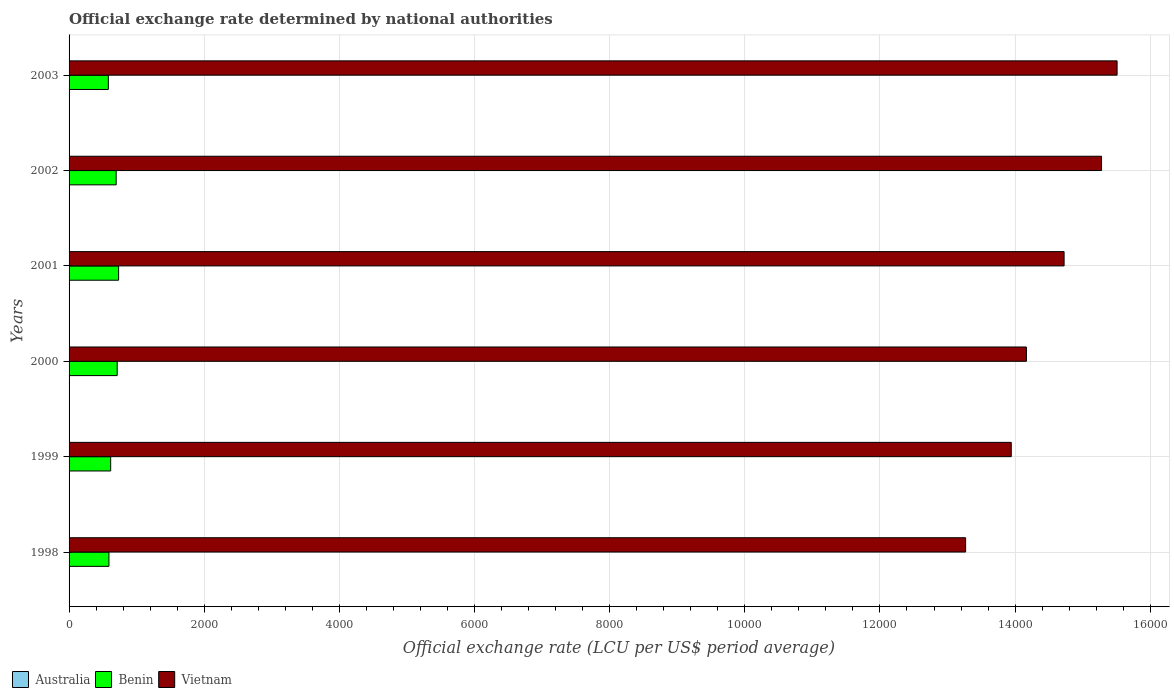Are the number of bars per tick equal to the number of legend labels?
Ensure brevity in your answer.  Yes. Are the number of bars on each tick of the Y-axis equal?
Ensure brevity in your answer.  Yes. How many bars are there on the 4th tick from the bottom?
Your answer should be compact. 3. What is the label of the 3rd group of bars from the top?
Your answer should be very brief. 2001. What is the official exchange rate in Australia in 2000?
Keep it short and to the point. 1.72. Across all years, what is the maximum official exchange rate in Vietnam?
Make the answer very short. 1.55e+04. Across all years, what is the minimum official exchange rate in Australia?
Provide a short and direct response. 1.54. What is the total official exchange rate in Vietnam in the graph?
Offer a very short reply. 8.69e+04. What is the difference between the official exchange rate in Benin in 1998 and that in 2001?
Your response must be concise. -143.09. What is the difference between the official exchange rate in Vietnam in 1999 and the official exchange rate in Benin in 2002?
Your response must be concise. 1.32e+04. What is the average official exchange rate in Benin per year?
Your answer should be very brief. 654.81. In the year 2003, what is the difference between the official exchange rate in Australia and official exchange rate in Vietnam?
Give a very brief answer. -1.55e+04. What is the ratio of the official exchange rate in Vietnam in 2000 to that in 2002?
Your answer should be very brief. 0.93. Is the official exchange rate in Australia in 1999 less than that in 2000?
Your answer should be compact. Yes. Is the difference between the official exchange rate in Australia in 1998 and 2002 greater than the difference between the official exchange rate in Vietnam in 1998 and 2002?
Your answer should be compact. Yes. What is the difference between the highest and the second highest official exchange rate in Australia?
Offer a very short reply. 0.09. What is the difference between the highest and the lowest official exchange rate in Australia?
Make the answer very short. 0.39. In how many years, is the official exchange rate in Australia greater than the average official exchange rate in Australia taken over all years?
Your answer should be compact. 3. What does the 2nd bar from the top in 1998 represents?
Provide a succinct answer. Benin. Are all the bars in the graph horizontal?
Your answer should be compact. Yes. How many years are there in the graph?
Provide a succinct answer. 6. Does the graph contain grids?
Keep it short and to the point. Yes. Where does the legend appear in the graph?
Offer a very short reply. Bottom left. How many legend labels are there?
Ensure brevity in your answer.  3. How are the legend labels stacked?
Keep it short and to the point. Horizontal. What is the title of the graph?
Provide a short and direct response. Official exchange rate determined by national authorities. Does "Mauritania" appear as one of the legend labels in the graph?
Ensure brevity in your answer.  No. What is the label or title of the X-axis?
Offer a very short reply. Official exchange rate (LCU per US$ period average). What is the Official exchange rate (LCU per US$ period average) of Australia in 1998?
Offer a terse response. 1.59. What is the Official exchange rate (LCU per US$ period average) of Benin in 1998?
Ensure brevity in your answer.  589.95. What is the Official exchange rate (LCU per US$ period average) of Vietnam in 1998?
Offer a very short reply. 1.33e+04. What is the Official exchange rate (LCU per US$ period average) in Australia in 1999?
Your response must be concise. 1.55. What is the Official exchange rate (LCU per US$ period average) in Benin in 1999?
Your answer should be compact. 615.7. What is the Official exchange rate (LCU per US$ period average) in Vietnam in 1999?
Your answer should be very brief. 1.39e+04. What is the Official exchange rate (LCU per US$ period average) of Australia in 2000?
Give a very brief answer. 1.72. What is the Official exchange rate (LCU per US$ period average) in Benin in 2000?
Offer a very short reply. 711.98. What is the Official exchange rate (LCU per US$ period average) of Vietnam in 2000?
Your answer should be very brief. 1.42e+04. What is the Official exchange rate (LCU per US$ period average) of Australia in 2001?
Give a very brief answer. 1.93. What is the Official exchange rate (LCU per US$ period average) in Benin in 2001?
Offer a very short reply. 733.04. What is the Official exchange rate (LCU per US$ period average) of Vietnam in 2001?
Make the answer very short. 1.47e+04. What is the Official exchange rate (LCU per US$ period average) in Australia in 2002?
Your answer should be compact. 1.84. What is the Official exchange rate (LCU per US$ period average) of Benin in 2002?
Keep it short and to the point. 696.99. What is the Official exchange rate (LCU per US$ period average) in Vietnam in 2002?
Offer a very short reply. 1.53e+04. What is the Official exchange rate (LCU per US$ period average) of Australia in 2003?
Provide a succinct answer. 1.54. What is the Official exchange rate (LCU per US$ period average) in Benin in 2003?
Make the answer very short. 581.2. What is the Official exchange rate (LCU per US$ period average) of Vietnam in 2003?
Your response must be concise. 1.55e+04. Across all years, what is the maximum Official exchange rate (LCU per US$ period average) in Australia?
Ensure brevity in your answer.  1.93. Across all years, what is the maximum Official exchange rate (LCU per US$ period average) of Benin?
Your answer should be compact. 733.04. Across all years, what is the maximum Official exchange rate (LCU per US$ period average) of Vietnam?
Keep it short and to the point. 1.55e+04. Across all years, what is the minimum Official exchange rate (LCU per US$ period average) of Australia?
Provide a succinct answer. 1.54. Across all years, what is the minimum Official exchange rate (LCU per US$ period average) of Benin?
Your answer should be very brief. 581.2. Across all years, what is the minimum Official exchange rate (LCU per US$ period average) in Vietnam?
Ensure brevity in your answer.  1.33e+04. What is the total Official exchange rate (LCU per US$ period average) of Australia in the graph?
Keep it short and to the point. 10.18. What is the total Official exchange rate (LCU per US$ period average) in Benin in the graph?
Provide a succinct answer. 3928.85. What is the total Official exchange rate (LCU per US$ period average) in Vietnam in the graph?
Provide a succinct answer. 8.69e+04. What is the difference between the Official exchange rate (LCU per US$ period average) in Australia in 1998 and that in 1999?
Keep it short and to the point. 0.04. What is the difference between the Official exchange rate (LCU per US$ period average) in Benin in 1998 and that in 1999?
Your answer should be compact. -25.75. What is the difference between the Official exchange rate (LCU per US$ period average) of Vietnam in 1998 and that in 1999?
Offer a terse response. -675.17. What is the difference between the Official exchange rate (LCU per US$ period average) in Australia in 1998 and that in 2000?
Provide a short and direct response. -0.13. What is the difference between the Official exchange rate (LCU per US$ period average) of Benin in 1998 and that in 2000?
Your answer should be very brief. -122.02. What is the difference between the Official exchange rate (LCU per US$ period average) of Vietnam in 1998 and that in 2000?
Provide a succinct answer. -899.75. What is the difference between the Official exchange rate (LCU per US$ period average) of Australia in 1998 and that in 2001?
Offer a very short reply. -0.34. What is the difference between the Official exchange rate (LCU per US$ period average) in Benin in 1998 and that in 2001?
Your answer should be very brief. -143.09. What is the difference between the Official exchange rate (LCU per US$ period average) in Vietnam in 1998 and that in 2001?
Provide a short and direct response. -1457.17. What is the difference between the Official exchange rate (LCU per US$ period average) in Australia in 1998 and that in 2002?
Your answer should be compact. -0.25. What is the difference between the Official exchange rate (LCU per US$ period average) of Benin in 1998 and that in 2002?
Make the answer very short. -107.04. What is the difference between the Official exchange rate (LCU per US$ period average) in Vietnam in 1998 and that in 2002?
Make the answer very short. -2011.5. What is the difference between the Official exchange rate (LCU per US$ period average) of Australia in 1998 and that in 2003?
Offer a terse response. 0.05. What is the difference between the Official exchange rate (LCU per US$ period average) of Benin in 1998 and that in 2003?
Ensure brevity in your answer.  8.75. What is the difference between the Official exchange rate (LCU per US$ period average) in Vietnam in 1998 and that in 2003?
Your response must be concise. -2241.58. What is the difference between the Official exchange rate (LCU per US$ period average) in Australia in 1999 and that in 2000?
Offer a very short reply. -0.17. What is the difference between the Official exchange rate (LCU per US$ period average) in Benin in 1999 and that in 2000?
Offer a terse response. -96.28. What is the difference between the Official exchange rate (LCU per US$ period average) in Vietnam in 1999 and that in 2000?
Offer a terse response. -224.58. What is the difference between the Official exchange rate (LCU per US$ period average) in Australia in 1999 and that in 2001?
Your response must be concise. -0.38. What is the difference between the Official exchange rate (LCU per US$ period average) in Benin in 1999 and that in 2001?
Your response must be concise. -117.34. What is the difference between the Official exchange rate (LCU per US$ period average) in Vietnam in 1999 and that in 2001?
Keep it short and to the point. -782. What is the difference between the Official exchange rate (LCU per US$ period average) of Australia in 1999 and that in 2002?
Your answer should be very brief. -0.29. What is the difference between the Official exchange rate (LCU per US$ period average) of Benin in 1999 and that in 2002?
Provide a short and direct response. -81.29. What is the difference between the Official exchange rate (LCU per US$ period average) in Vietnam in 1999 and that in 2002?
Your answer should be compact. -1336.33. What is the difference between the Official exchange rate (LCU per US$ period average) in Australia in 1999 and that in 2003?
Keep it short and to the point. 0.01. What is the difference between the Official exchange rate (LCU per US$ period average) of Benin in 1999 and that in 2003?
Provide a succinct answer. 34.5. What is the difference between the Official exchange rate (LCU per US$ period average) in Vietnam in 1999 and that in 2003?
Your response must be concise. -1566.42. What is the difference between the Official exchange rate (LCU per US$ period average) in Australia in 2000 and that in 2001?
Give a very brief answer. -0.21. What is the difference between the Official exchange rate (LCU per US$ period average) in Benin in 2000 and that in 2001?
Keep it short and to the point. -21.06. What is the difference between the Official exchange rate (LCU per US$ period average) of Vietnam in 2000 and that in 2001?
Give a very brief answer. -557.42. What is the difference between the Official exchange rate (LCU per US$ period average) in Australia in 2000 and that in 2002?
Make the answer very short. -0.12. What is the difference between the Official exchange rate (LCU per US$ period average) of Benin in 2000 and that in 2002?
Provide a succinct answer. 14.99. What is the difference between the Official exchange rate (LCU per US$ period average) in Vietnam in 2000 and that in 2002?
Provide a short and direct response. -1111.75. What is the difference between the Official exchange rate (LCU per US$ period average) in Australia in 2000 and that in 2003?
Keep it short and to the point. 0.18. What is the difference between the Official exchange rate (LCU per US$ period average) in Benin in 2000 and that in 2003?
Give a very brief answer. 130.78. What is the difference between the Official exchange rate (LCU per US$ period average) in Vietnam in 2000 and that in 2003?
Ensure brevity in your answer.  -1341.83. What is the difference between the Official exchange rate (LCU per US$ period average) of Australia in 2001 and that in 2002?
Ensure brevity in your answer.  0.09. What is the difference between the Official exchange rate (LCU per US$ period average) of Benin in 2001 and that in 2002?
Your answer should be very brief. 36.05. What is the difference between the Official exchange rate (LCU per US$ period average) of Vietnam in 2001 and that in 2002?
Offer a terse response. -554.33. What is the difference between the Official exchange rate (LCU per US$ period average) in Australia in 2001 and that in 2003?
Your response must be concise. 0.39. What is the difference between the Official exchange rate (LCU per US$ period average) of Benin in 2001 and that in 2003?
Give a very brief answer. 151.84. What is the difference between the Official exchange rate (LCU per US$ period average) of Vietnam in 2001 and that in 2003?
Your answer should be very brief. -784.42. What is the difference between the Official exchange rate (LCU per US$ period average) of Australia in 2002 and that in 2003?
Ensure brevity in your answer.  0.3. What is the difference between the Official exchange rate (LCU per US$ period average) of Benin in 2002 and that in 2003?
Make the answer very short. 115.79. What is the difference between the Official exchange rate (LCU per US$ period average) in Vietnam in 2002 and that in 2003?
Offer a very short reply. -230.08. What is the difference between the Official exchange rate (LCU per US$ period average) of Australia in 1998 and the Official exchange rate (LCU per US$ period average) of Benin in 1999?
Provide a succinct answer. -614.11. What is the difference between the Official exchange rate (LCU per US$ period average) of Australia in 1998 and the Official exchange rate (LCU per US$ period average) of Vietnam in 1999?
Your response must be concise. -1.39e+04. What is the difference between the Official exchange rate (LCU per US$ period average) in Benin in 1998 and the Official exchange rate (LCU per US$ period average) in Vietnam in 1999?
Make the answer very short. -1.34e+04. What is the difference between the Official exchange rate (LCU per US$ period average) of Australia in 1998 and the Official exchange rate (LCU per US$ period average) of Benin in 2000?
Provide a succinct answer. -710.38. What is the difference between the Official exchange rate (LCU per US$ period average) of Australia in 1998 and the Official exchange rate (LCU per US$ period average) of Vietnam in 2000?
Your answer should be compact. -1.42e+04. What is the difference between the Official exchange rate (LCU per US$ period average) of Benin in 1998 and the Official exchange rate (LCU per US$ period average) of Vietnam in 2000?
Ensure brevity in your answer.  -1.36e+04. What is the difference between the Official exchange rate (LCU per US$ period average) in Australia in 1998 and the Official exchange rate (LCU per US$ period average) in Benin in 2001?
Offer a very short reply. -731.45. What is the difference between the Official exchange rate (LCU per US$ period average) of Australia in 1998 and the Official exchange rate (LCU per US$ period average) of Vietnam in 2001?
Give a very brief answer. -1.47e+04. What is the difference between the Official exchange rate (LCU per US$ period average) in Benin in 1998 and the Official exchange rate (LCU per US$ period average) in Vietnam in 2001?
Offer a terse response. -1.41e+04. What is the difference between the Official exchange rate (LCU per US$ period average) in Australia in 1998 and the Official exchange rate (LCU per US$ period average) in Benin in 2002?
Ensure brevity in your answer.  -695.4. What is the difference between the Official exchange rate (LCU per US$ period average) of Australia in 1998 and the Official exchange rate (LCU per US$ period average) of Vietnam in 2002?
Your response must be concise. -1.53e+04. What is the difference between the Official exchange rate (LCU per US$ period average) in Benin in 1998 and the Official exchange rate (LCU per US$ period average) in Vietnam in 2002?
Give a very brief answer. -1.47e+04. What is the difference between the Official exchange rate (LCU per US$ period average) in Australia in 1998 and the Official exchange rate (LCU per US$ period average) in Benin in 2003?
Make the answer very short. -579.61. What is the difference between the Official exchange rate (LCU per US$ period average) of Australia in 1998 and the Official exchange rate (LCU per US$ period average) of Vietnam in 2003?
Ensure brevity in your answer.  -1.55e+04. What is the difference between the Official exchange rate (LCU per US$ period average) of Benin in 1998 and the Official exchange rate (LCU per US$ period average) of Vietnam in 2003?
Give a very brief answer. -1.49e+04. What is the difference between the Official exchange rate (LCU per US$ period average) of Australia in 1999 and the Official exchange rate (LCU per US$ period average) of Benin in 2000?
Keep it short and to the point. -710.43. What is the difference between the Official exchange rate (LCU per US$ period average) in Australia in 1999 and the Official exchange rate (LCU per US$ period average) in Vietnam in 2000?
Your response must be concise. -1.42e+04. What is the difference between the Official exchange rate (LCU per US$ period average) of Benin in 1999 and the Official exchange rate (LCU per US$ period average) of Vietnam in 2000?
Make the answer very short. -1.36e+04. What is the difference between the Official exchange rate (LCU per US$ period average) in Australia in 1999 and the Official exchange rate (LCU per US$ period average) in Benin in 2001?
Your response must be concise. -731.49. What is the difference between the Official exchange rate (LCU per US$ period average) of Australia in 1999 and the Official exchange rate (LCU per US$ period average) of Vietnam in 2001?
Ensure brevity in your answer.  -1.47e+04. What is the difference between the Official exchange rate (LCU per US$ period average) in Benin in 1999 and the Official exchange rate (LCU per US$ period average) in Vietnam in 2001?
Make the answer very short. -1.41e+04. What is the difference between the Official exchange rate (LCU per US$ period average) in Australia in 1999 and the Official exchange rate (LCU per US$ period average) in Benin in 2002?
Give a very brief answer. -695.44. What is the difference between the Official exchange rate (LCU per US$ period average) in Australia in 1999 and the Official exchange rate (LCU per US$ period average) in Vietnam in 2002?
Give a very brief answer. -1.53e+04. What is the difference between the Official exchange rate (LCU per US$ period average) in Benin in 1999 and the Official exchange rate (LCU per US$ period average) in Vietnam in 2002?
Offer a terse response. -1.47e+04. What is the difference between the Official exchange rate (LCU per US$ period average) in Australia in 1999 and the Official exchange rate (LCU per US$ period average) in Benin in 2003?
Give a very brief answer. -579.65. What is the difference between the Official exchange rate (LCU per US$ period average) in Australia in 1999 and the Official exchange rate (LCU per US$ period average) in Vietnam in 2003?
Your response must be concise. -1.55e+04. What is the difference between the Official exchange rate (LCU per US$ period average) of Benin in 1999 and the Official exchange rate (LCU per US$ period average) of Vietnam in 2003?
Ensure brevity in your answer.  -1.49e+04. What is the difference between the Official exchange rate (LCU per US$ period average) of Australia in 2000 and the Official exchange rate (LCU per US$ period average) of Benin in 2001?
Your answer should be compact. -731.31. What is the difference between the Official exchange rate (LCU per US$ period average) of Australia in 2000 and the Official exchange rate (LCU per US$ period average) of Vietnam in 2001?
Your response must be concise. -1.47e+04. What is the difference between the Official exchange rate (LCU per US$ period average) in Benin in 2000 and the Official exchange rate (LCU per US$ period average) in Vietnam in 2001?
Keep it short and to the point. -1.40e+04. What is the difference between the Official exchange rate (LCU per US$ period average) of Australia in 2000 and the Official exchange rate (LCU per US$ period average) of Benin in 2002?
Give a very brief answer. -695.26. What is the difference between the Official exchange rate (LCU per US$ period average) in Australia in 2000 and the Official exchange rate (LCU per US$ period average) in Vietnam in 2002?
Offer a very short reply. -1.53e+04. What is the difference between the Official exchange rate (LCU per US$ period average) of Benin in 2000 and the Official exchange rate (LCU per US$ period average) of Vietnam in 2002?
Ensure brevity in your answer.  -1.46e+04. What is the difference between the Official exchange rate (LCU per US$ period average) of Australia in 2000 and the Official exchange rate (LCU per US$ period average) of Benin in 2003?
Ensure brevity in your answer.  -579.48. What is the difference between the Official exchange rate (LCU per US$ period average) of Australia in 2000 and the Official exchange rate (LCU per US$ period average) of Vietnam in 2003?
Provide a succinct answer. -1.55e+04. What is the difference between the Official exchange rate (LCU per US$ period average) in Benin in 2000 and the Official exchange rate (LCU per US$ period average) in Vietnam in 2003?
Keep it short and to the point. -1.48e+04. What is the difference between the Official exchange rate (LCU per US$ period average) in Australia in 2001 and the Official exchange rate (LCU per US$ period average) in Benin in 2002?
Provide a short and direct response. -695.05. What is the difference between the Official exchange rate (LCU per US$ period average) of Australia in 2001 and the Official exchange rate (LCU per US$ period average) of Vietnam in 2002?
Provide a short and direct response. -1.53e+04. What is the difference between the Official exchange rate (LCU per US$ period average) in Benin in 2001 and the Official exchange rate (LCU per US$ period average) in Vietnam in 2002?
Make the answer very short. -1.45e+04. What is the difference between the Official exchange rate (LCU per US$ period average) in Australia in 2001 and the Official exchange rate (LCU per US$ period average) in Benin in 2003?
Give a very brief answer. -579.27. What is the difference between the Official exchange rate (LCU per US$ period average) of Australia in 2001 and the Official exchange rate (LCU per US$ period average) of Vietnam in 2003?
Ensure brevity in your answer.  -1.55e+04. What is the difference between the Official exchange rate (LCU per US$ period average) of Benin in 2001 and the Official exchange rate (LCU per US$ period average) of Vietnam in 2003?
Keep it short and to the point. -1.48e+04. What is the difference between the Official exchange rate (LCU per US$ period average) of Australia in 2002 and the Official exchange rate (LCU per US$ period average) of Benin in 2003?
Offer a very short reply. -579.36. What is the difference between the Official exchange rate (LCU per US$ period average) of Australia in 2002 and the Official exchange rate (LCU per US$ period average) of Vietnam in 2003?
Your answer should be compact. -1.55e+04. What is the difference between the Official exchange rate (LCU per US$ period average) of Benin in 2002 and the Official exchange rate (LCU per US$ period average) of Vietnam in 2003?
Your answer should be very brief. -1.48e+04. What is the average Official exchange rate (LCU per US$ period average) in Australia per year?
Provide a short and direct response. 1.7. What is the average Official exchange rate (LCU per US$ period average) of Benin per year?
Provide a short and direct response. 654.81. What is the average Official exchange rate (LCU per US$ period average) of Vietnam per year?
Ensure brevity in your answer.  1.45e+04. In the year 1998, what is the difference between the Official exchange rate (LCU per US$ period average) of Australia and Official exchange rate (LCU per US$ period average) of Benin?
Provide a succinct answer. -588.36. In the year 1998, what is the difference between the Official exchange rate (LCU per US$ period average) of Australia and Official exchange rate (LCU per US$ period average) of Vietnam?
Keep it short and to the point. -1.33e+04. In the year 1998, what is the difference between the Official exchange rate (LCU per US$ period average) of Benin and Official exchange rate (LCU per US$ period average) of Vietnam?
Give a very brief answer. -1.27e+04. In the year 1999, what is the difference between the Official exchange rate (LCU per US$ period average) of Australia and Official exchange rate (LCU per US$ period average) of Benin?
Provide a succinct answer. -614.15. In the year 1999, what is the difference between the Official exchange rate (LCU per US$ period average) of Australia and Official exchange rate (LCU per US$ period average) of Vietnam?
Make the answer very short. -1.39e+04. In the year 1999, what is the difference between the Official exchange rate (LCU per US$ period average) in Benin and Official exchange rate (LCU per US$ period average) in Vietnam?
Make the answer very short. -1.33e+04. In the year 2000, what is the difference between the Official exchange rate (LCU per US$ period average) of Australia and Official exchange rate (LCU per US$ period average) of Benin?
Your answer should be compact. -710.25. In the year 2000, what is the difference between the Official exchange rate (LCU per US$ period average) in Australia and Official exchange rate (LCU per US$ period average) in Vietnam?
Your response must be concise. -1.42e+04. In the year 2000, what is the difference between the Official exchange rate (LCU per US$ period average) in Benin and Official exchange rate (LCU per US$ period average) in Vietnam?
Provide a short and direct response. -1.35e+04. In the year 2001, what is the difference between the Official exchange rate (LCU per US$ period average) in Australia and Official exchange rate (LCU per US$ period average) in Benin?
Your answer should be very brief. -731.11. In the year 2001, what is the difference between the Official exchange rate (LCU per US$ period average) of Australia and Official exchange rate (LCU per US$ period average) of Vietnam?
Offer a terse response. -1.47e+04. In the year 2001, what is the difference between the Official exchange rate (LCU per US$ period average) of Benin and Official exchange rate (LCU per US$ period average) of Vietnam?
Your answer should be very brief. -1.40e+04. In the year 2002, what is the difference between the Official exchange rate (LCU per US$ period average) of Australia and Official exchange rate (LCU per US$ period average) of Benin?
Ensure brevity in your answer.  -695.15. In the year 2002, what is the difference between the Official exchange rate (LCU per US$ period average) of Australia and Official exchange rate (LCU per US$ period average) of Vietnam?
Give a very brief answer. -1.53e+04. In the year 2002, what is the difference between the Official exchange rate (LCU per US$ period average) of Benin and Official exchange rate (LCU per US$ period average) of Vietnam?
Make the answer very short. -1.46e+04. In the year 2003, what is the difference between the Official exchange rate (LCU per US$ period average) of Australia and Official exchange rate (LCU per US$ period average) of Benin?
Ensure brevity in your answer.  -579.66. In the year 2003, what is the difference between the Official exchange rate (LCU per US$ period average) in Australia and Official exchange rate (LCU per US$ period average) in Vietnam?
Your answer should be compact. -1.55e+04. In the year 2003, what is the difference between the Official exchange rate (LCU per US$ period average) in Benin and Official exchange rate (LCU per US$ period average) in Vietnam?
Your response must be concise. -1.49e+04. What is the ratio of the Official exchange rate (LCU per US$ period average) of Benin in 1998 to that in 1999?
Provide a short and direct response. 0.96. What is the ratio of the Official exchange rate (LCU per US$ period average) of Vietnam in 1998 to that in 1999?
Ensure brevity in your answer.  0.95. What is the ratio of the Official exchange rate (LCU per US$ period average) in Australia in 1998 to that in 2000?
Your response must be concise. 0.92. What is the ratio of the Official exchange rate (LCU per US$ period average) of Benin in 1998 to that in 2000?
Your answer should be compact. 0.83. What is the ratio of the Official exchange rate (LCU per US$ period average) in Vietnam in 1998 to that in 2000?
Ensure brevity in your answer.  0.94. What is the ratio of the Official exchange rate (LCU per US$ period average) in Australia in 1998 to that in 2001?
Offer a terse response. 0.82. What is the ratio of the Official exchange rate (LCU per US$ period average) of Benin in 1998 to that in 2001?
Your answer should be compact. 0.8. What is the ratio of the Official exchange rate (LCU per US$ period average) of Vietnam in 1998 to that in 2001?
Offer a terse response. 0.9. What is the ratio of the Official exchange rate (LCU per US$ period average) in Australia in 1998 to that in 2002?
Your answer should be very brief. 0.86. What is the ratio of the Official exchange rate (LCU per US$ period average) in Benin in 1998 to that in 2002?
Make the answer very short. 0.85. What is the ratio of the Official exchange rate (LCU per US$ period average) in Vietnam in 1998 to that in 2002?
Ensure brevity in your answer.  0.87. What is the ratio of the Official exchange rate (LCU per US$ period average) in Australia in 1998 to that in 2003?
Provide a succinct answer. 1.03. What is the ratio of the Official exchange rate (LCU per US$ period average) of Benin in 1998 to that in 2003?
Provide a succinct answer. 1.02. What is the ratio of the Official exchange rate (LCU per US$ period average) in Vietnam in 1998 to that in 2003?
Keep it short and to the point. 0.86. What is the ratio of the Official exchange rate (LCU per US$ period average) of Australia in 1999 to that in 2000?
Your answer should be very brief. 0.9. What is the ratio of the Official exchange rate (LCU per US$ period average) in Benin in 1999 to that in 2000?
Offer a terse response. 0.86. What is the ratio of the Official exchange rate (LCU per US$ period average) of Vietnam in 1999 to that in 2000?
Provide a succinct answer. 0.98. What is the ratio of the Official exchange rate (LCU per US$ period average) of Australia in 1999 to that in 2001?
Offer a terse response. 0.8. What is the ratio of the Official exchange rate (LCU per US$ period average) of Benin in 1999 to that in 2001?
Your answer should be very brief. 0.84. What is the ratio of the Official exchange rate (LCU per US$ period average) in Vietnam in 1999 to that in 2001?
Keep it short and to the point. 0.95. What is the ratio of the Official exchange rate (LCU per US$ period average) of Australia in 1999 to that in 2002?
Provide a short and direct response. 0.84. What is the ratio of the Official exchange rate (LCU per US$ period average) of Benin in 1999 to that in 2002?
Offer a very short reply. 0.88. What is the ratio of the Official exchange rate (LCU per US$ period average) of Vietnam in 1999 to that in 2002?
Make the answer very short. 0.91. What is the ratio of the Official exchange rate (LCU per US$ period average) in Benin in 1999 to that in 2003?
Your answer should be very brief. 1.06. What is the ratio of the Official exchange rate (LCU per US$ period average) in Vietnam in 1999 to that in 2003?
Your answer should be compact. 0.9. What is the ratio of the Official exchange rate (LCU per US$ period average) in Australia in 2000 to that in 2001?
Provide a short and direct response. 0.89. What is the ratio of the Official exchange rate (LCU per US$ period average) in Benin in 2000 to that in 2001?
Your answer should be compact. 0.97. What is the ratio of the Official exchange rate (LCU per US$ period average) in Vietnam in 2000 to that in 2001?
Offer a terse response. 0.96. What is the ratio of the Official exchange rate (LCU per US$ period average) of Australia in 2000 to that in 2002?
Offer a terse response. 0.94. What is the ratio of the Official exchange rate (LCU per US$ period average) in Benin in 2000 to that in 2002?
Provide a succinct answer. 1.02. What is the ratio of the Official exchange rate (LCU per US$ period average) in Vietnam in 2000 to that in 2002?
Your response must be concise. 0.93. What is the ratio of the Official exchange rate (LCU per US$ period average) in Australia in 2000 to that in 2003?
Provide a succinct answer. 1.12. What is the ratio of the Official exchange rate (LCU per US$ period average) in Benin in 2000 to that in 2003?
Ensure brevity in your answer.  1.23. What is the ratio of the Official exchange rate (LCU per US$ period average) in Vietnam in 2000 to that in 2003?
Offer a terse response. 0.91. What is the ratio of the Official exchange rate (LCU per US$ period average) of Australia in 2001 to that in 2002?
Your answer should be compact. 1.05. What is the ratio of the Official exchange rate (LCU per US$ period average) of Benin in 2001 to that in 2002?
Provide a short and direct response. 1.05. What is the ratio of the Official exchange rate (LCU per US$ period average) of Vietnam in 2001 to that in 2002?
Your answer should be very brief. 0.96. What is the ratio of the Official exchange rate (LCU per US$ period average) in Australia in 2001 to that in 2003?
Your answer should be very brief. 1.25. What is the ratio of the Official exchange rate (LCU per US$ period average) in Benin in 2001 to that in 2003?
Your answer should be very brief. 1.26. What is the ratio of the Official exchange rate (LCU per US$ period average) in Vietnam in 2001 to that in 2003?
Provide a succinct answer. 0.95. What is the ratio of the Official exchange rate (LCU per US$ period average) of Australia in 2002 to that in 2003?
Give a very brief answer. 1.19. What is the ratio of the Official exchange rate (LCU per US$ period average) of Benin in 2002 to that in 2003?
Offer a very short reply. 1.2. What is the ratio of the Official exchange rate (LCU per US$ period average) in Vietnam in 2002 to that in 2003?
Offer a very short reply. 0.99. What is the difference between the highest and the second highest Official exchange rate (LCU per US$ period average) of Australia?
Keep it short and to the point. 0.09. What is the difference between the highest and the second highest Official exchange rate (LCU per US$ period average) of Benin?
Provide a succinct answer. 21.06. What is the difference between the highest and the second highest Official exchange rate (LCU per US$ period average) in Vietnam?
Offer a very short reply. 230.08. What is the difference between the highest and the lowest Official exchange rate (LCU per US$ period average) of Australia?
Ensure brevity in your answer.  0.39. What is the difference between the highest and the lowest Official exchange rate (LCU per US$ period average) in Benin?
Ensure brevity in your answer.  151.84. What is the difference between the highest and the lowest Official exchange rate (LCU per US$ period average) in Vietnam?
Your answer should be very brief. 2241.58. 